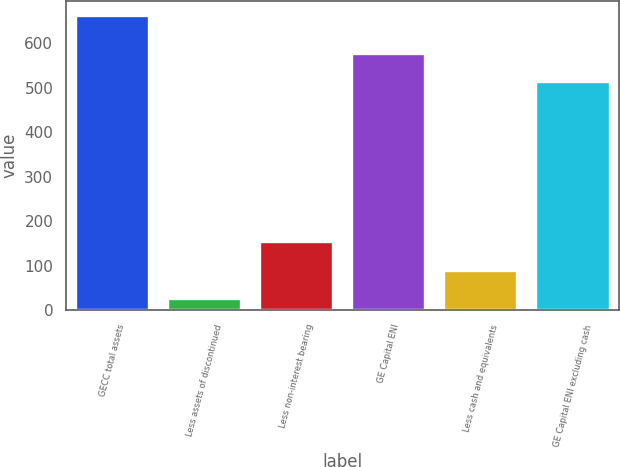<chart> <loc_0><loc_0><loc_500><loc_500><bar_chart><fcel>GECC total assets<fcel>Less assets of discontinued<fcel>Less non-interest bearing<fcel>GE Capital ENI<fcel>Less cash and equivalents<fcel>GE Capital ENI excluding cash<nl><fcel>661<fcel>25.1<fcel>152.28<fcel>576.39<fcel>88.69<fcel>512.8<nl></chart> 